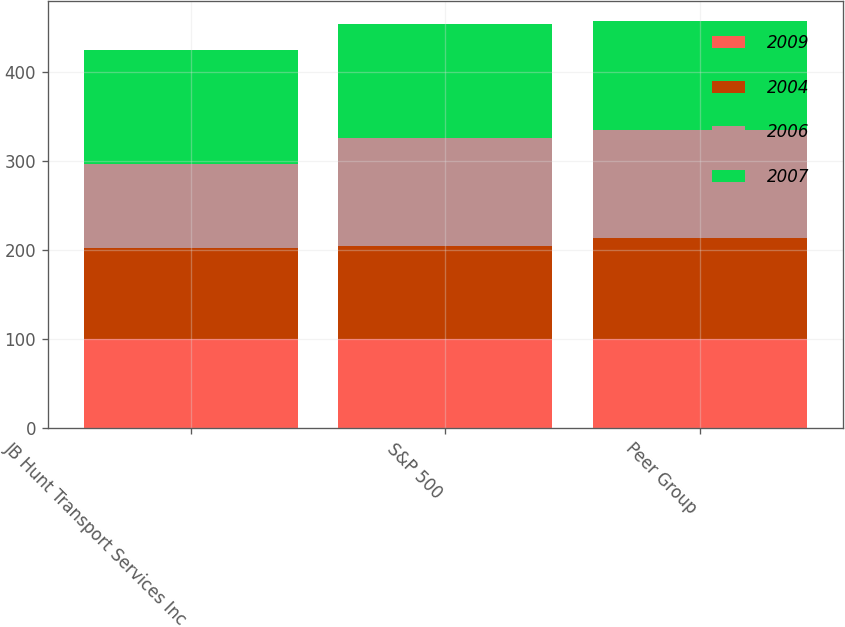Convert chart. <chart><loc_0><loc_0><loc_500><loc_500><stacked_bar_chart><ecel><fcel>JB Hunt Transport Services Inc<fcel>S&P 500<fcel>Peer Group<nl><fcel>2009<fcel>100<fcel>100<fcel>100<nl><fcel>2004<fcel>102.15<fcel>104.91<fcel>113.84<nl><fcel>2006<fcel>95.07<fcel>121.48<fcel>120.76<nl><fcel>2007<fcel>127.79<fcel>128.16<fcel>122.69<nl></chart> 